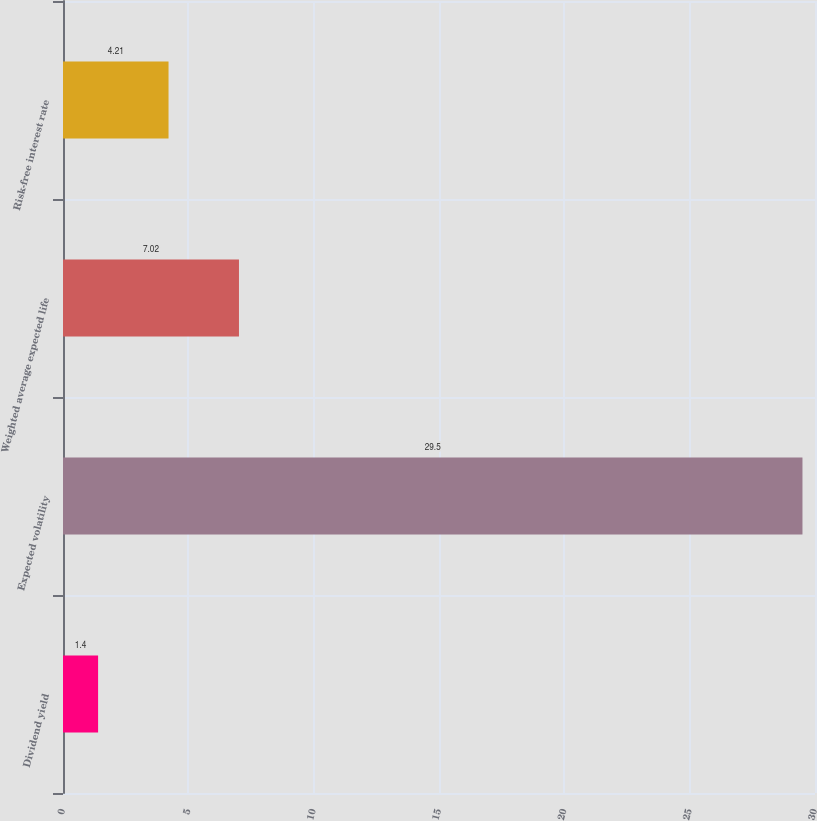Convert chart to OTSL. <chart><loc_0><loc_0><loc_500><loc_500><bar_chart><fcel>Dividend yield<fcel>Expected volatility<fcel>Weighted average expected life<fcel>Risk-free interest rate<nl><fcel>1.4<fcel>29.5<fcel>7.02<fcel>4.21<nl></chart> 